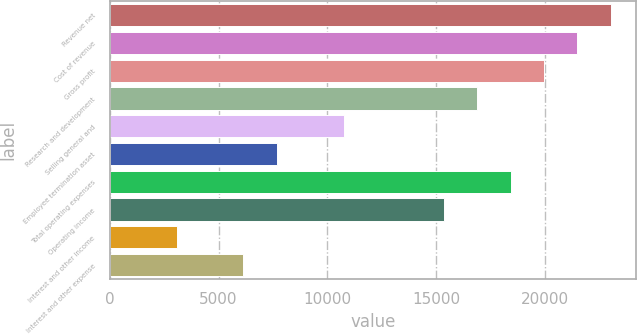Convert chart to OTSL. <chart><loc_0><loc_0><loc_500><loc_500><bar_chart><fcel>Revenue net<fcel>Cost of revenue<fcel>Gross profit<fcel>Research and development<fcel>Selling general and<fcel>Employee termination asset<fcel>Total operating expenses<fcel>Operating income<fcel>Interest and other income<fcel>Interest and other expense<nl><fcel>23024.5<fcel>21489.8<fcel>19955.1<fcel>16885.7<fcel>10746.9<fcel>7677.48<fcel>18420.4<fcel>15351<fcel>3073.38<fcel>6142.78<nl></chart> 